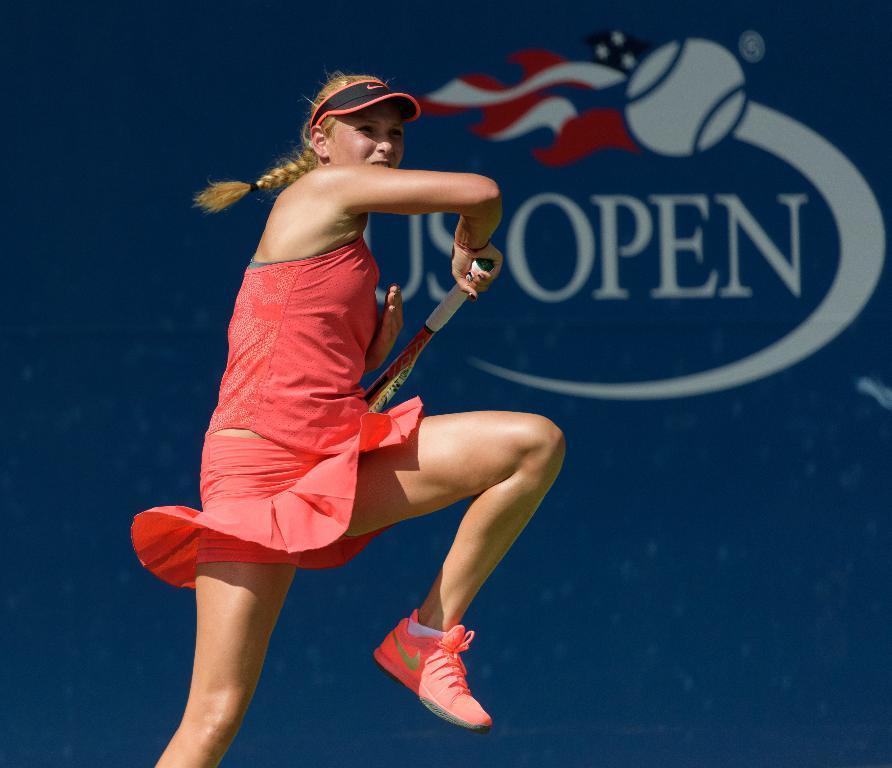How would you summarize this image in a sentence or two? A woman is playing the Tennis she wear a red color dress and shoes. 